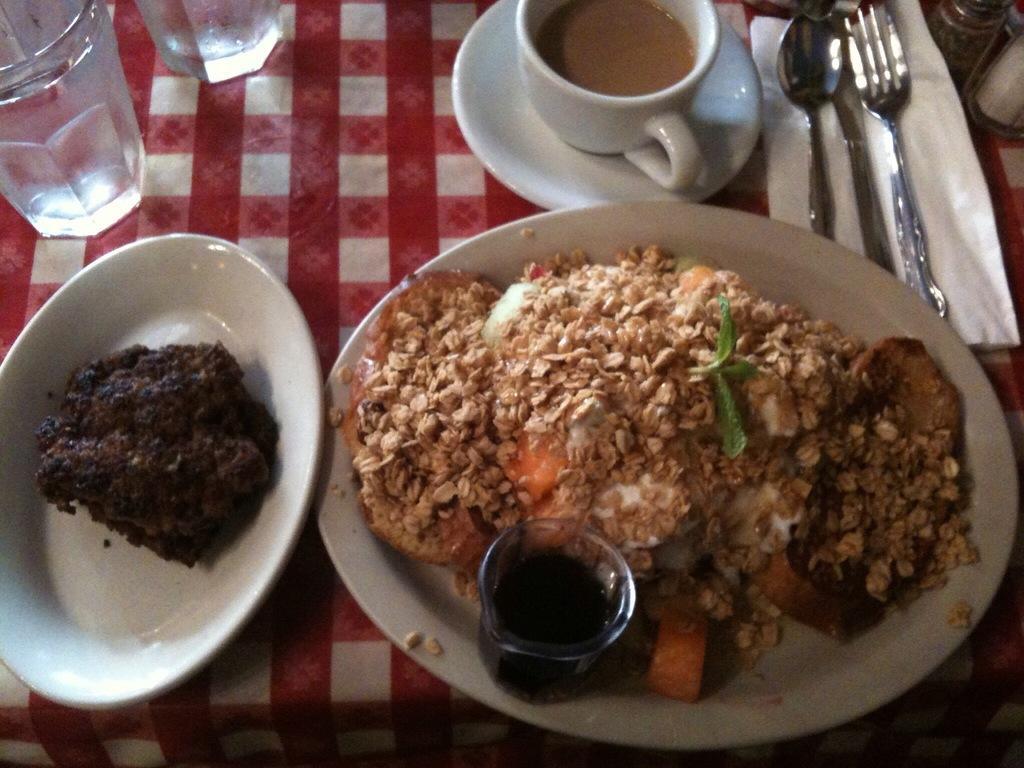Describe this image in one or two sentences. In this image there are plates in the center and in the plates there is food and also there is a cup, in the cup there is tea and there is a saucer, spoons, fork, tissue paper, glasses. And at the bottom there is a cloth. 